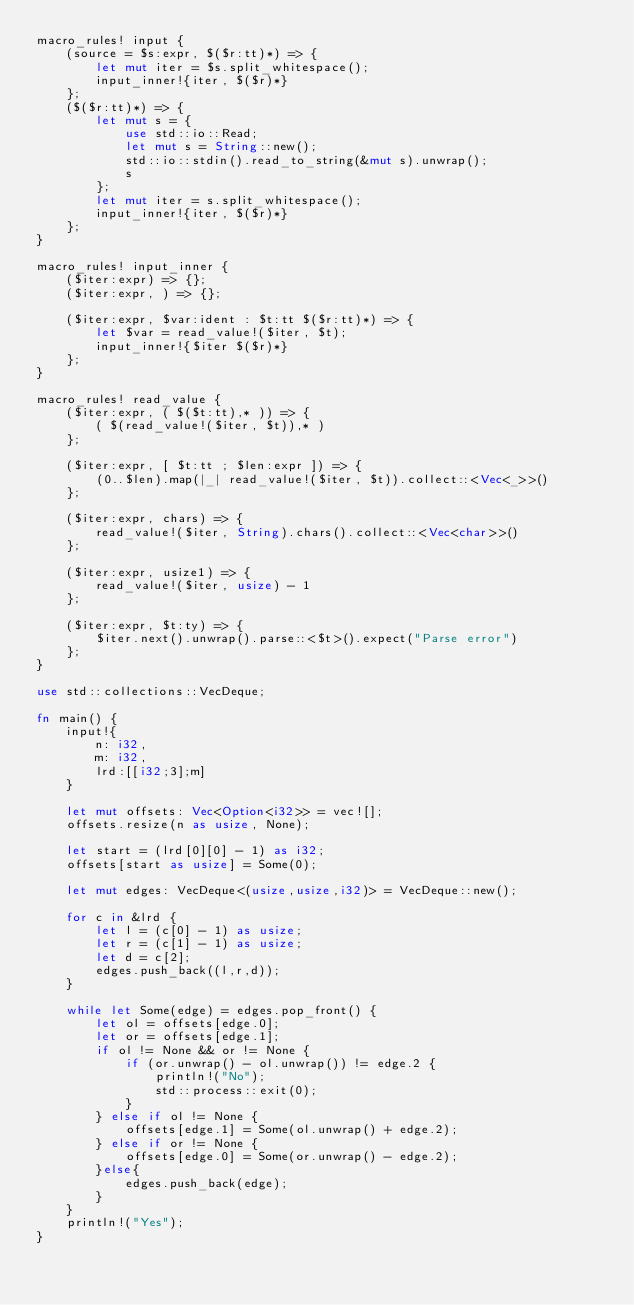<code> <loc_0><loc_0><loc_500><loc_500><_Rust_>macro_rules! input {
    (source = $s:expr, $($r:tt)*) => {
        let mut iter = $s.split_whitespace();
        input_inner!{iter, $($r)*}
    };
    ($($r:tt)*) => {
        let mut s = {
            use std::io::Read;
            let mut s = String::new();
            std::io::stdin().read_to_string(&mut s).unwrap();
            s
        };
        let mut iter = s.split_whitespace();
        input_inner!{iter, $($r)*}
    };
}

macro_rules! input_inner {
    ($iter:expr) => {};
    ($iter:expr, ) => {};
 
    ($iter:expr, $var:ident : $t:tt $($r:tt)*) => {
        let $var = read_value!($iter, $t);
        input_inner!{$iter $($r)*}
    };
}

macro_rules! read_value {
    ($iter:expr, ( $($t:tt),* )) => {
        ( $(read_value!($iter, $t)),* )
    };
 
    ($iter:expr, [ $t:tt ; $len:expr ]) => {
        (0..$len).map(|_| read_value!($iter, $t)).collect::<Vec<_>>()
    };
 
    ($iter:expr, chars) => {
        read_value!($iter, String).chars().collect::<Vec<char>>()
    };
 
    ($iter:expr, usize1) => {
        read_value!($iter, usize) - 1
    };
 
    ($iter:expr, $t:ty) => {
        $iter.next().unwrap().parse::<$t>().expect("Parse error")
    };
}

use std::collections::VecDeque;

fn main() {
    input!{
        n: i32,
        m: i32,
        lrd:[[i32;3];m]
    }

    let mut offsets: Vec<Option<i32>> = vec![];
    offsets.resize(n as usize, None);

    let start = (lrd[0][0] - 1) as i32;
    offsets[start as usize] = Some(0);

    let mut edges: VecDeque<(usize,usize,i32)> = VecDeque::new();

    for c in &lrd {
        let l = (c[0] - 1) as usize;
        let r = (c[1] - 1) as usize;
        let d = c[2];
        edges.push_back((l,r,d));
    }

    while let Some(edge) = edges.pop_front() {
        let ol = offsets[edge.0];
        let or = offsets[edge.1];
        if ol != None && or != None {
            if (or.unwrap() - ol.unwrap()) != edge.2 {
                println!("No");
                std::process::exit(0);
            }
        } else if ol != None {
            offsets[edge.1] = Some(ol.unwrap() + edge.2);
        } else if or != None {
            offsets[edge.0] = Some(or.unwrap() - edge.2);
        }else{
            edges.push_back(edge);
        }
    }
    println!("Yes");
}
</code> 